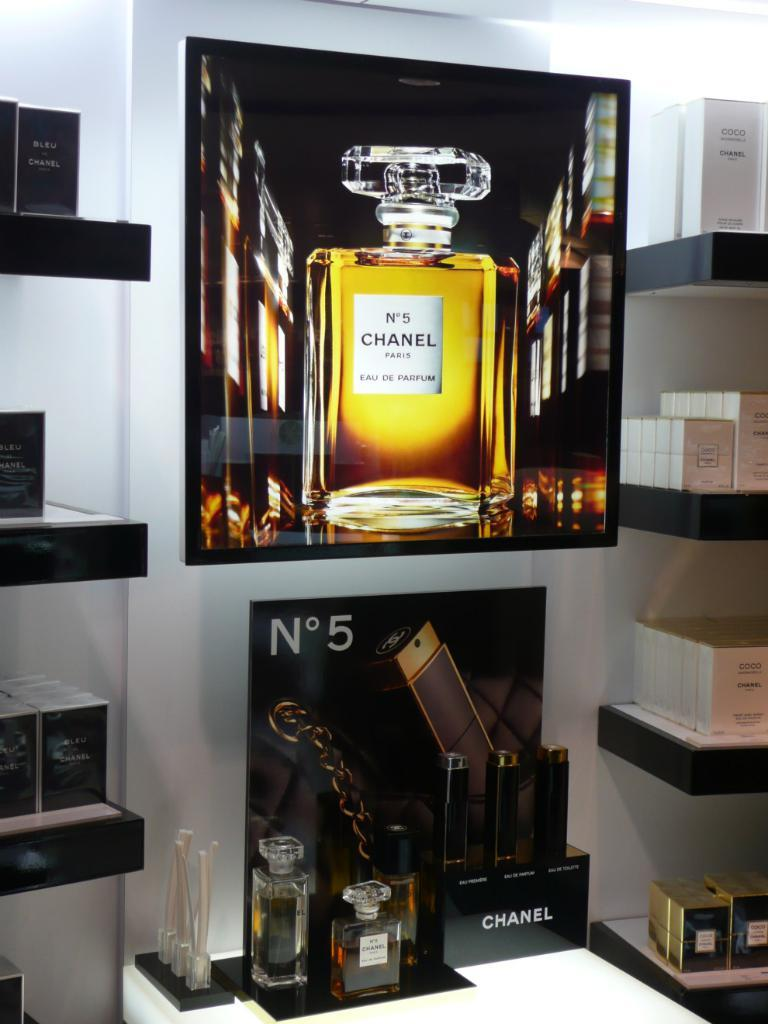<image>
Present a compact description of the photo's key features. No 5 Chanel perfume is manufactured somewhere in Paris. 